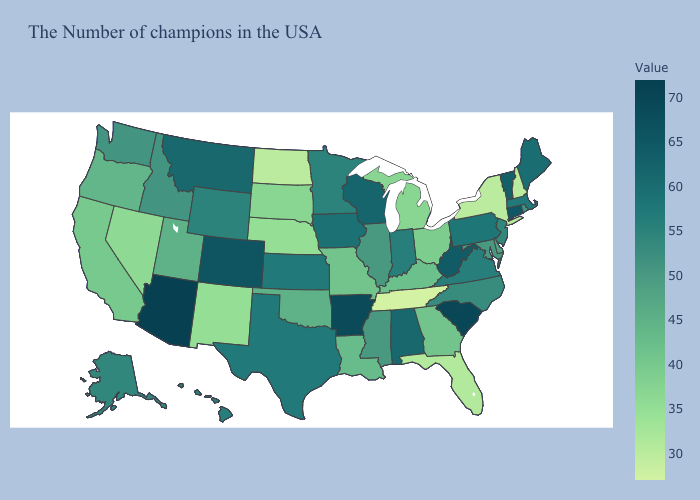Does West Virginia have the highest value in the South?
Quick response, please. No. Which states hav the highest value in the Northeast?
Answer briefly. Connecticut. Among the states that border Massachusetts , does Connecticut have the highest value?
Answer briefly. Yes. Which states have the highest value in the USA?
Short answer required. Arizona. Does Arizona have the highest value in the USA?
Be succinct. Yes. Does Georgia have the lowest value in the South?
Keep it brief. No. Which states have the lowest value in the MidWest?
Keep it brief. North Dakota. 